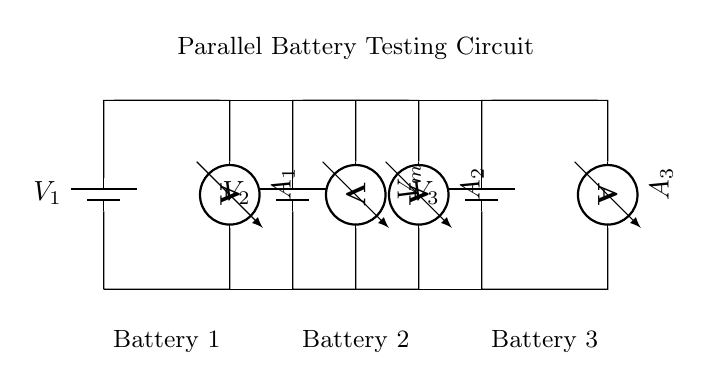What type of circuit is shown in the diagram? The circuit is a parallel circuit as indicated by multiple branches connecting components directly across the same voltage source.
Answer: Parallel What is the total number of batteries connected in the circuit? There are three batteries connected in the circuit as seen in the diagram.
Answer: Three What does the ammeter measure in this circuit? Each ammeter measures the current flowing through its respective branch, allowing for comparison of battery performance.
Answer: Current What is the voltage across each battery in this configuration? Each battery has the same voltage across it because it is a parallel setup, where voltage remains constant across all branches.
Answer: Same How many ammeters are present in the circuit? There are three ammeters present, each corresponding to a different battery in the diagram.
Answer: Three What component is used to measure voltage in this circuit? A voltmeter is used in the circuit to measure the voltage across the batteries, shown connected vertically from the top to the bottom.
Answer: Voltmeter Which batteries are compared in this circuit? All three batteries are connected in parallel, allowing for direct comparison of their performance and characteristics.
Answer: All three batteries 